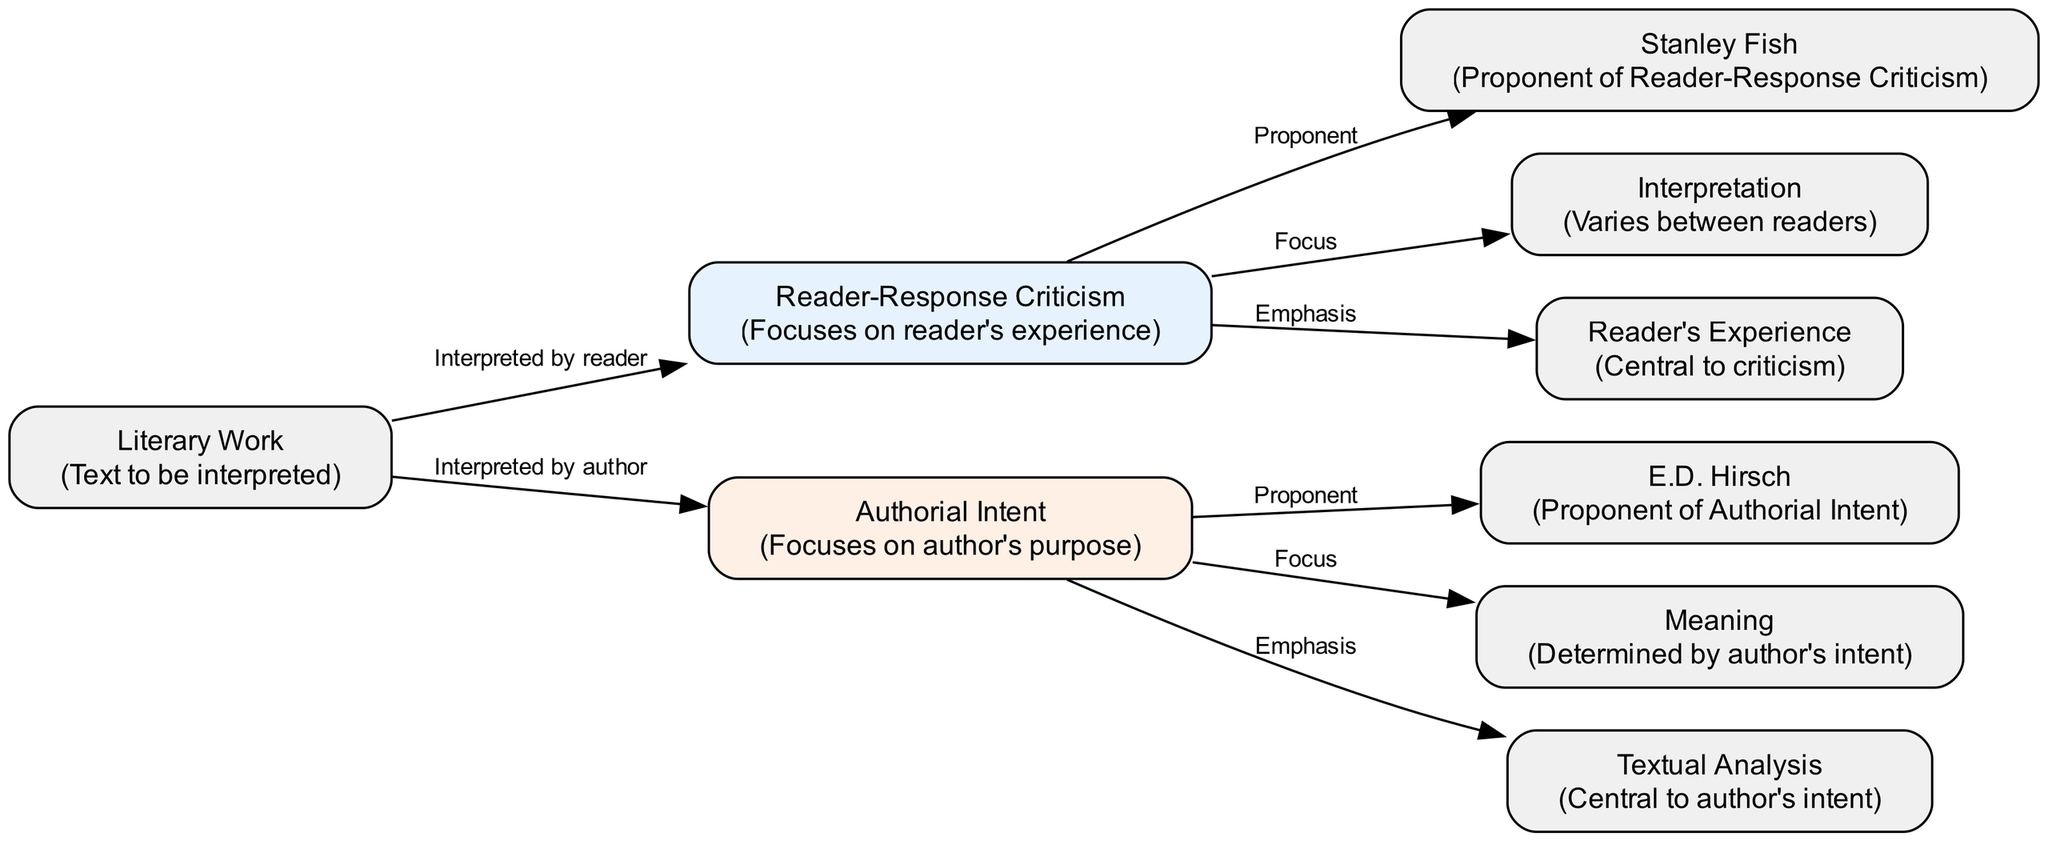What is the focus of Reader-Response Criticism? In the diagram, Reader-Response Criticism is linked with the 'Focus' edge to the 'Interpretation' node, indicating that its primary concern is with the reader's interpretation of a text. Thus, the focus can be directly identified as "varies between readers".
Answer: varies between readers Who is the proponent of Authorial Intent? The diagram identifies E.D. Hirsch as the 'Proponent' of Authorial Intent, as indicated by the directed edge from the Authorial Intent node to the E.D. Hirsch node.
Answer: E.D. Hirsch What is emphasized in Reader-Response Criticism? The diagram illustrates that Reader-Response Criticism emphasizes 'Reader's Experience'. This is shown by the edge labeled 'Emphasis' connecting Reader-Response Criticism to Reader's Experience.
Answer: Reader's Experience How many nodes are present in the diagram? By counting the number of distinct labeled nodes in the diagram, we find eight nodes representing different concepts and critics related to the two approaches.
Answer: 9 What does the 'Meaning' node connect to? The 'Meaning' node connects directly to the 'Authorial Intent' node, which indicates that meaning is described as being 'Determined by author's intent' in this approach.
Answer: Authorial Intent Which concept is central to Authorial Intent? The diagram indicates that 'Textual Analysis' is the central aspect of Authorial Intent as it is linked to Authorial Intent by the edge marked 'Emphasis'.
Answer: Textual Analysis What role does the 'Literary Work' node play in Reader-Response Criticism? The 'Literary Work' node is connected to the 'Reader-Response Criticism' node by the edge labeled 'Interpreted by reader', indicating that the literary work is interpreted through the lens of the reader's personal experience.
Answer: Interpreted by reader Which node represents a focus on author's purpose? The diagram shows that the 'Authorial Intent' node directly represents a focus on the author's purpose as indicated by its connection to the 'Focus' labeled edge and the 'Meaning' node.
Answer: Authorial Intent What are the two main critical approaches illustrated in the diagram? The diagram distinctly presents two approaches: Reader-Response Criticism and Authorial Intent, which are the primary nodes shown on either side of the diagram for comparison.
Answer: Reader-Response Criticism and Authorial Intent 